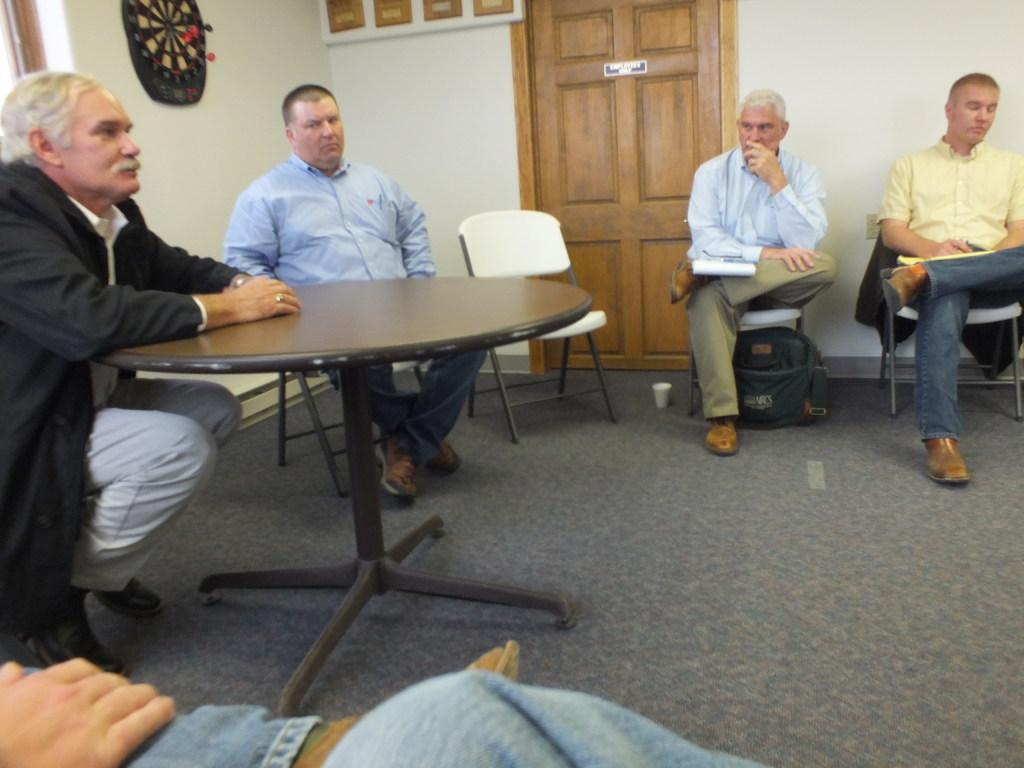What are the people in the image doing? The people in the image are sitting. How are the people arranged in the image? The people are sitting in a shape. What is in front of the people? There is a table in front of the people. What can be seen on the wall in the image? There is an arrow game on the wall in the image. What architectural feature is present in the image? There is a door in the image. What type of pancake is being served at the hospital in the image? There is no hospital or pancake present in the image. 